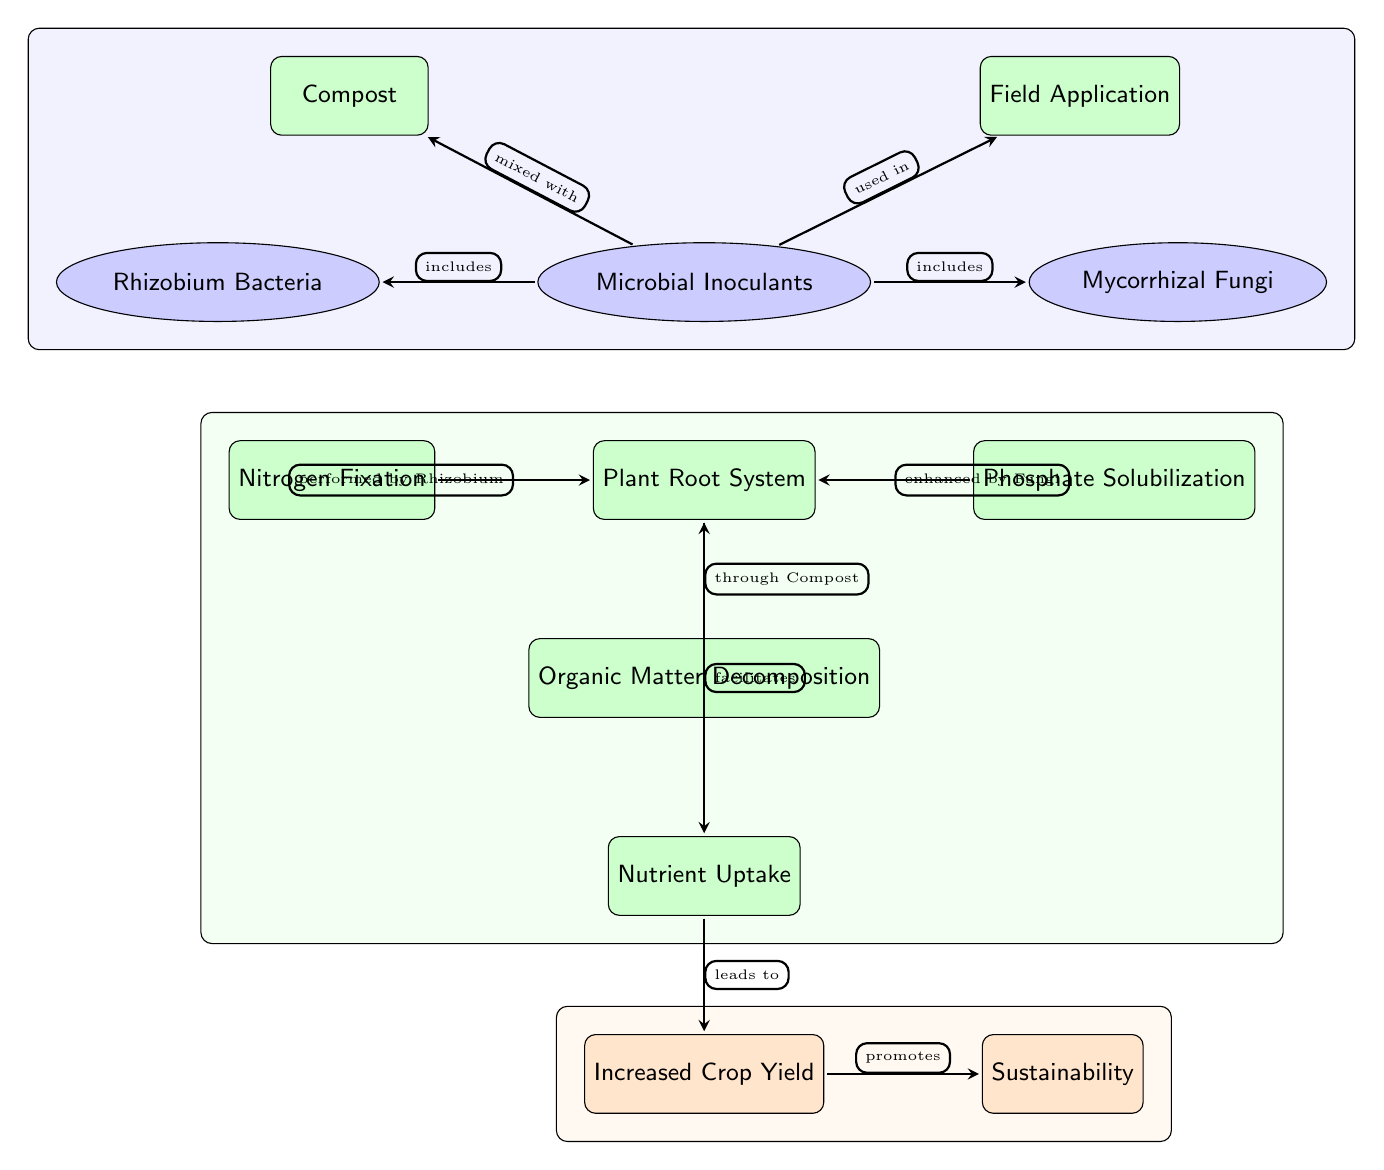What are the two types of microbial inoculants mentioned in the diagram? The diagram lists "Rhizobium Bacteria" and "Mycorrhizal Fungi" as types of microbial inoculants connected to the main node.
Answer: Rhizobium Bacteria, Mycorrhizal Fungi What process is performed by Rhizobium? The diagram indicates the process "Nitrogen Fixation" is associated with Rhizobium, connecting it to the Plant Root System node.
Answer: Nitrogen Fixation How many processes contribute to the Plant Root System? The diagram shows four processes (Nitrogen Fixation, Phosphate Solubilization, Organic Matter Decomposition, and the Plant Root System itself) that are connected above it.
Answer: Four What is the final output of the diagram? The diagram indicates that the "Increased Crop Yield" leads to "Sustainability," which is marked as the ultimate outcome of the microbial inoculants and processes outlined.
Answer: Sustainability What role does compost play in the diagram? According to the diagram, compost is used in conjunction with microbial inoculants to enhance the "Organic Matter Decomposition" process, which subsequently supports the Plant Root System.
Answer: Organic Matter Decomposition How do microbial inoculants impact nutrient uptake? The diagram illustrates that after facilitating the Plant Root System, the processes culminate in increased Nutrient Uptake which directly leads to increased crop yield.
Answer: Increased Crop Yield 